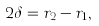<formula> <loc_0><loc_0><loc_500><loc_500>2 \delta = r _ { 2 } - r _ { 1 } ,</formula> 